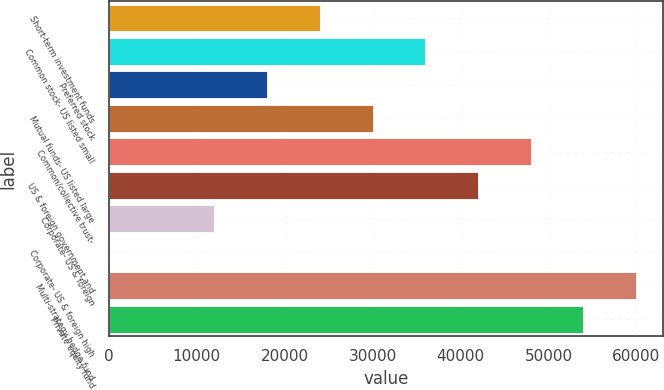Convert chart to OTSL. <chart><loc_0><loc_0><loc_500><loc_500><bar_chart><fcel>Short-term investment funds<fcel>Common stock- US listed small<fcel>Preferred stock<fcel>Mutual funds- US listed large<fcel>Common/collective trust-<fcel>US & foreign government and<fcel>Corporate- US & foreign<fcel>Corporate- US & foreign high<fcel>Multi-strategy hedge fund<fcel>Private equity fund<nl><fcel>23991.1<fcel>35986.4<fcel>17993.5<fcel>29988.8<fcel>47981.7<fcel>41984.1<fcel>11995.8<fcel>0.5<fcel>59977<fcel>53979.3<nl></chart> 